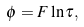Convert formula to latex. <formula><loc_0><loc_0><loc_500><loc_500>\phi = F \ln \tau ,</formula> 